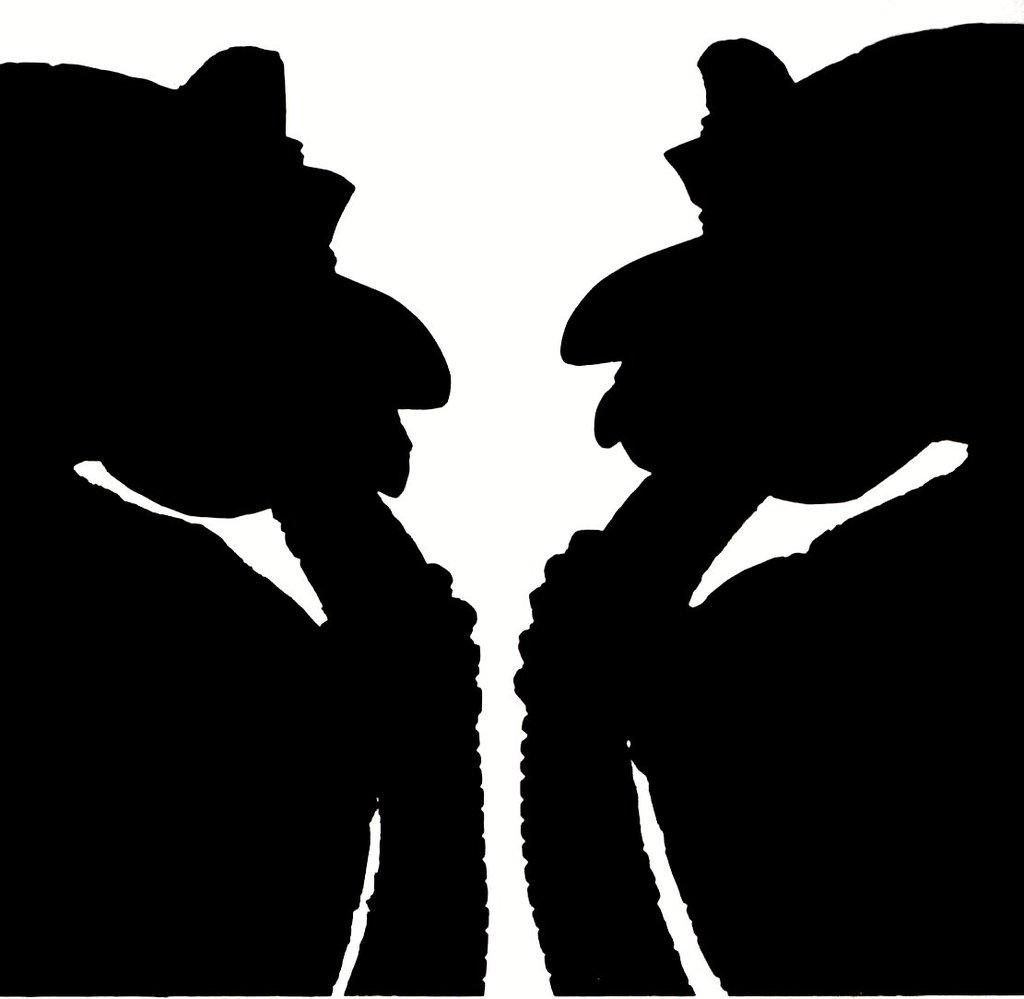How does the spy use the flight information and cord in the image? There is no image provided, and therefore no information about a spy, flight, or cord can be determined. 